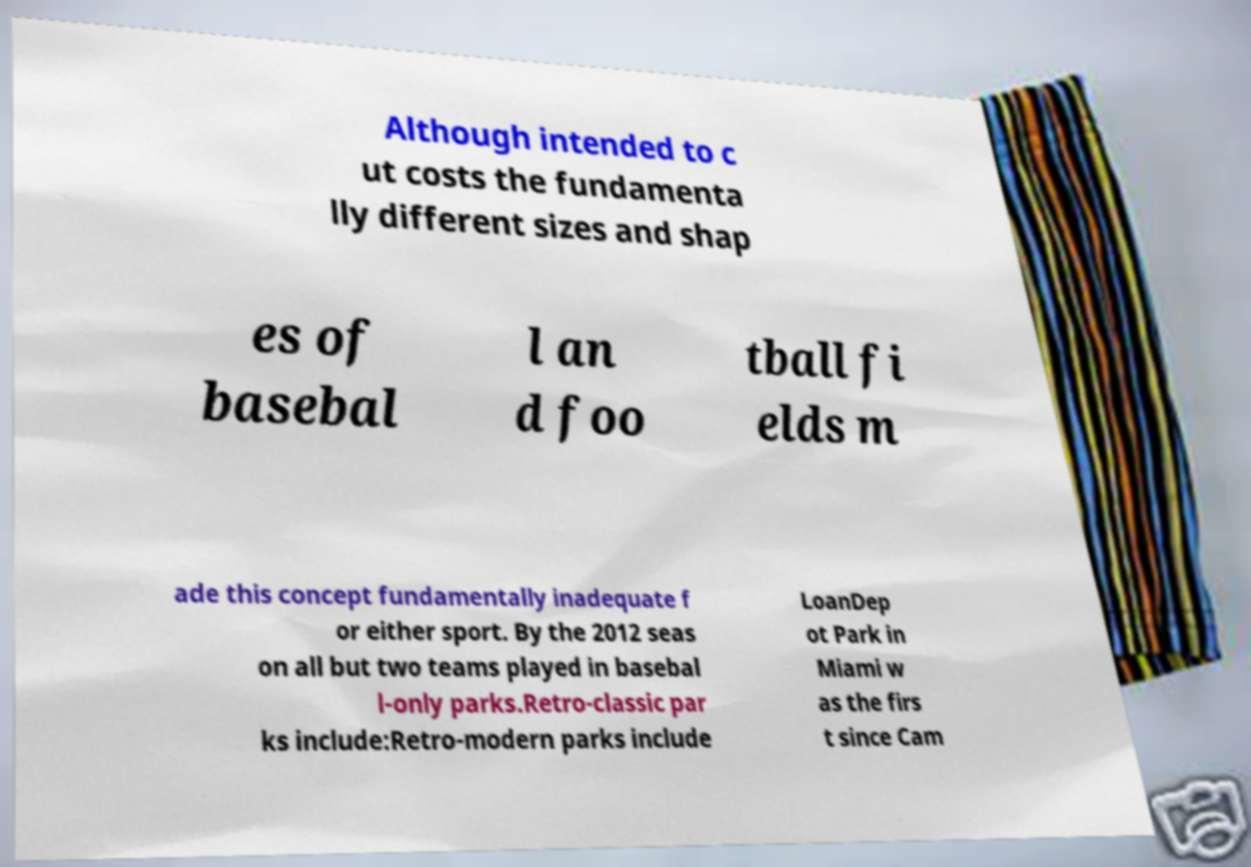Can you read and provide the text displayed in the image?This photo seems to have some interesting text. Can you extract and type it out for me? Although intended to c ut costs the fundamenta lly different sizes and shap es of basebal l an d foo tball fi elds m ade this concept fundamentally inadequate f or either sport. By the 2012 seas on all but two teams played in basebal l-only parks.Retro-classic par ks include:Retro-modern parks include LoanDep ot Park in Miami w as the firs t since Cam 